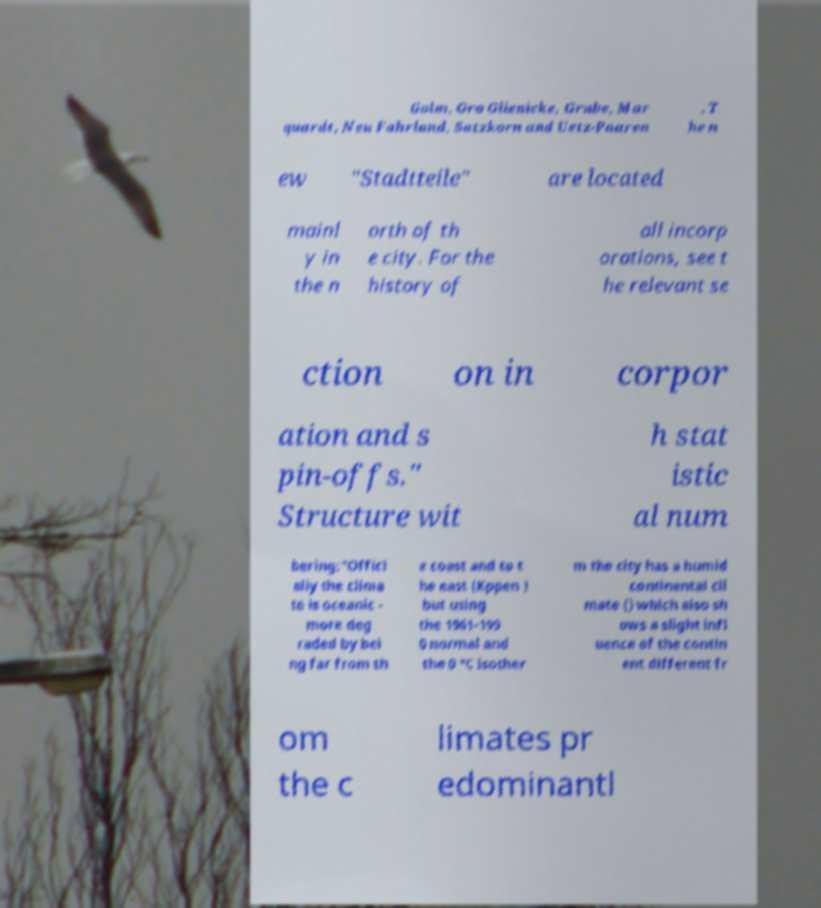I need the written content from this picture converted into text. Can you do that? Golm, Gro Glienicke, Grube, Mar quardt, Neu Fahrland, Satzkorn and Uetz-Paaren . T he n ew "Stadtteile" are located mainl y in the n orth of th e city. For the history of all incorp orations, see t he relevant se ction on in corpor ation and s pin-offs." Structure wit h stat istic al num bering:"Offici ally the clima te is oceanic - more deg raded by bei ng far from th e coast and to t he east (Kppen ) but using the 1961-199 0 normal and the 0 °C isother m the city has a humid continental cli mate () which also sh ows a slight infl uence of the contin ent different fr om the c limates pr edominantl 